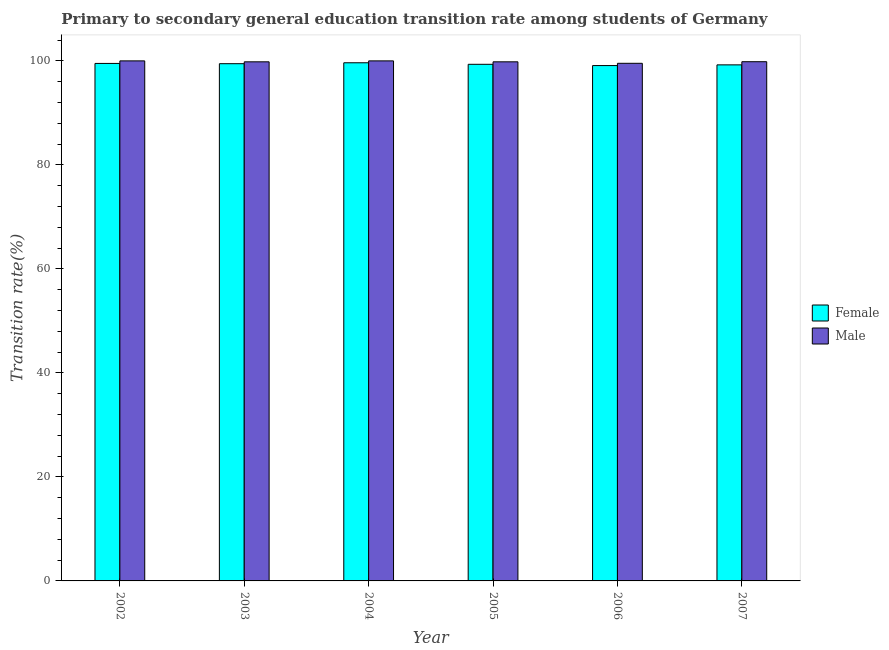How many groups of bars are there?
Make the answer very short. 6. Are the number of bars on each tick of the X-axis equal?
Your answer should be compact. Yes. What is the label of the 3rd group of bars from the left?
Ensure brevity in your answer.  2004. In how many cases, is the number of bars for a given year not equal to the number of legend labels?
Your answer should be very brief. 0. What is the transition rate among female students in 2007?
Your answer should be very brief. 99.23. Across all years, what is the maximum transition rate among male students?
Give a very brief answer. 100. Across all years, what is the minimum transition rate among female students?
Offer a terse response. 99.1. In which year was the transition rate among female students maximum?
Ensure brevity in your answer.  2004. In which year was the transition rate among female students minimum?
Keep it short and to the point. 2006. What is the total transition rate among female students in the graph?
Offer a very short reply. 596.28. What is the difference between the transition rate among female students in 2006 and that in 2007?
Keep it short and to the point. -0.13. What is the difference between the transition rate among male students in 2002 and the transition rate among female students in 2004?
Your answer should be very brief. 0. What is the average transition rate among male students per year?
Keep it short and to the point. 99.84. In the year 2003, what is the difference between the transition rate among female students and transition rate among male students?
Provide a succinct answer. 0. What is the ratio of the transition rate among female students in 2005 to that in 2006?
Provide a succinct answer. 1. Is the transition rate among female students in 2003 less than that in 2006?
Your answer should be very brief. No. What is the difference between the highest and the lowest transition rate among female students?
Provide a succinct answer. 0.54. In how many years, is the transition rate among female students greater than the average transition rate among female students taken over all years?
Provide a short and direct response. 3. Is the sum of the transition rate among female students in 2003 and 2007 greater than the maximum transition rate among male students across all years?
Provide a succinct answer. Yes. What does the 2nd bar from the left in 2004 represents?
Provide a succinct answer. Male. What does the 2nd bar from the right in 2006 represents?
Provide a short and direct response. Female. How many bars are there?
Ensure brevity in your answer.  12. How many years are there in the graph?
Keep it short and to the point. 6. Are the values on the major ticks of Y-axis written in scientific E-notation?
Your response must be concise. No. Does the graph contain any zero values?
Offer a very short reply. No. Does the graph contain grids?
Your response must be concise. No. Where does the legend appear in the graph?
Provide a succinct answer. Center right. What is the title of the graph?
Provide a short and direct response. Primary to secondary general education transition rate among students of Germany. Does "Formally registered" appear as one of the legend labels in the graph?
Your answer should be compact. No. What is the label or title of the Y-axis?
Offer a very short reply. Transition rate(%). What is the Transition rate(%) in Female in 2002?
Ensure brevity in your answer.  99.51. What is the Transition rate(%) in Female in 2003?
Offer a terse response. 99.46. What is the Transition rate(%) of Male in 2003?
Give a very brief answer. 99.82. What is the Transition rate(%) in Female in 2004?
Offer a very short reply. 99.64. What is the Transition rate(%) in Male in 2004?
Keep it short and to the point. 100. What is the Transition rate(%) in Female in 2005?
Give a very brief answer. 99.34. What is the Transition rate(%) in Male in 2005?
Offer a terse response. 99.82. What is the Transition rate(%) in Female in 2006?
Make the answer very short. 99.1. What is the Transition rate(%) in Male in 2006?
Offer a terse response. 99.53. What is the Transition rate(%) of Female in 2007?
Ensure brevity in your answer.  99.23. What is the Transition rate(%) in Male in 2007?
Offer a terse response. 99.84. Across all years, what is the maximum Transition rate(%) in Female?
Offer a terse response. 99.64. Across all years, what is the minimum Transition rate(%) of Female?
Offer a terse response. 99.1. Across all years, what is the minimum Transition rate(%) in Male?
Your response must be concise. 99.53. What is the total Transition rate(%) in Female in the graph?
Provide a succinct answer. 596.28. What is the total Transition rate(%) of Male in the graph?
Provide a succinct answer. 599.01. What is the difference between the Transition rate(%) in Female in 2002 and that in 2003?
Your answer should be very brief. 0.05. What is the difference between the Transition rate(%) in Male in 2002 and that in 2003?
Your answer should be compact. 0.18. What is the difference between the Transition rate(%) of Female in 2002 and that in 2004?
Make the answer very short. -0.13. What is the difference between the Transition rate(%) of Female in 2002 and that in 2005?
Your answer should be compact. 0.17. What is the difference between the Transition rate(%) of Male in 2002 and that in 2005?
Keep it short and to the point. 0.18. What is the difference between the Transition rate(%) of Female in 2002 and that in 2006?
Provide a succinct answer. 0.41. What is the difference between the Transition rate(%) of Male in 2002 and that in 2006?
Make the answer very short. 0.47. What is the difference between the Transition rate(%) of Female in 2002 and that in 2007?
Offer a very short reply. 0.28. What is the difference between the Transition rate(%) of Male in 2002 and that in 2007?
Give a very brief answer. 0.16. What is the difference between the Transition rate(%) of Female in 2003 and that in 2004?
Make the answer very short. -0.18. What is the difference between the Transition rate(%) in Male in 2003 and that in 2004?
Your response must be concise. -0.18. What is the difference between the Transition rate(%) of Female in 2003 and that in 2005?
Your answer should be very brief. 0.12. What is the difference between the Transition rate(%) in Male in 2003 and that in 2005?
Give a very brief answer. 0. What is the difference between the Transition rate(%) in Female in 2003 and that in 2006?
Provide a succinct answer. 0.36. What is the difference between the Transition rate(%) in Male in 2003 and that in 2006?
Ensure brevity in your answer.  0.28. What is the difference between the Transition rate(%) of Female in 2003 and that in 2007?
Offer a terse response. 0.23. What is the difference between the Transition rate(%) of Male in 2003 and that in 2007?
Offer a very short reply. -0.02. What is the difference between the Transition rate(%) of Female in 2004 and that in 2005?
Ensure brevity in your answer.  0.3. What is the difference between the Transition rate(%) of Male in 2004 and that in 2005?
Make the answer very short. 0.18. What is the difference between the Transition rate(%) of Female in 2004 and that in 2006?
Ensure brevity in your answer.  0.54. What is the difference between the Transition rate(%) in Male in 2004 and that in 2006?
Provide a succinct answer. 0.47. What is the difference between the Transition rate(%) of Female in 2004 and that in 2007?
Offer a very short reply. 0.41. What is the difference between the Transition rate(%) in Male in 2004 and that in 2007?
Your response must be concise. 0.16. What is the difference between the Transition rate(%) of Female in 2005 and that in 2006?
Your answer should be very brief. 0.24. What is the difference between the Transition rate(%) in Male in 2005 and that in 2006?
Your answer should be very brief. 0.28. What is the difference between the Transition rate(%) of Female in 2005 and that in 2007?
Provide a short and direct response. 0.11. What is the difference between the Transition rate(%) of Male in 2005 and that in 2007?
Ensure brevity in your answer.  -0.02. What is the difference between the Transition rate(%) in Female in 2006 and that in 2007?
Offer a very short reply. -0.13. What is the difference between the Transition rate(%) in Male in 2006 and that in 2007?
Ensure brevity in your answer.  -0.3. What is the difference between the Transition rate(%) of Female in 2002 and the Transition rate(%) of Male in 2003?
Your response must be concise. -0.31. What is the difference between the Transition rate(%) in Female in 2002 and the Transition rate(%) in Male in 2004?
Provide a short and direct response. -0.49. What is the difference between the Transition rate(%) in Female in 2002 and the Transition rate(%) in Male in 2005?
Your answer should be very brief. -0.31. What is the difference between the Transition rate(%) of Female in 2002 and the Transition rate(%) of Male in 2006?
Ensure brevity in your answer.  -0.02. What is the difference between the Transition rate(%) of Female in 2002 and the Transition rate(%) of Male in 2007?
Your response must be concise. -0.33. What is the difference between the Transition rate(%) in Female in 2003 and the Transition rate(%) in Male in 2004?
Offer a terse response. -0.54. What is the difference between the Transition rate(%) of Female in 2003 and the Transition rate(%) of Male in 2005?
Give a very brief answer. -0.36. What is the difference between the Transition rate(%) in Female in 2003 and the Transition rate(%) in Male in 2006?
Offer a very short reply. -0.08. What is the difference between the Transition rate(%) in Female in 2003 and the Transition rate(%) in Male in 2007?
Ensure brevity in your answer.  -0.38. What is the difference between the Transition rate(%) in Female in 2004 and the Transition rate(%) in Male in 2005?
Your answer should be compact. -0.18. What is the difference between the Transition rate(%) of Female in 2004 and the Transition rate(%) of Male in 2006?
Your answer should be compact. 0.1. What is the difference between the Transition rate(%) of Female in 2004 and the Transition rate(%) of Male in 2007?
Keep it short and to the point. -0.2. What is the difference between the Transition rate(%) in Female in 2005 and the Transition rate(%) in Male in 2006?
Provide a short and direct response. -0.19. What is the difference between the Transition rate(%) of Female in 2005 and the Transition rate(%) of Male in 2007?
Offer a very short reply. -0.5. What is the difference between the Transition rate(%) in Female in 2006 and the Transition rate(%) in Male in 2007?
Your answer should be compact. -0.74. What is the average Transition rate(%) in Female per year?
Offer a terse response. 99.38. What is the average Transition rate(%) in Male per year?
Ensure brevity in your answer.  99.84. In the year 2002, what is the difference between the Transition rate(%) in Female and Transition rate(%) in Male?
Your answer should be very brief. -0.49. In the year 2003, what is the difference between the Transition rate(%) of Female and Transition rate(%) of Male?
Provide a succinct answer. -0.36. In the year 2004, what is the difference between the Transition rate(%) of Female and Transition rate(%) of Male?
Offer a terse response. -0.36. In the year 2005, what is the difference between the Transition rate(%) in Female and Transition rate(%) in Male?
Provide a succinct answer. -0.48. In the year 2006, what is the difference between the Transition rate(%) of Female and Transition rate(%) of Male?
Ensure brevity in your answer.  -0.44. In the year 2007, what is the difference between the Transition rate(%) in Female and Transition rate(%) in Male?
Provide a short and direct response. -0.61. What is the ratio of the Transition rate(%) in Female in 2002 to that in 2004?
Provide a succinct answer. 1. What is the ratio of the Transition rate(%) in Male in 2002 to that in 2004?
Offer a terse response. 1. What is the ratio of the Transition rate(%) in Female in 2002 to that in 2005?
Provide a short and direct response. 1. What is the ratio of the Transition rate(%) of Male in 2002 to that in 2005?
Provide a succinct answer. 1. What is the ratio of the Transition rate(%) of Male in 2002 to that in 2006?
Keep it short and to the point. 1. What is the ratio of the Transition rate(%) in Male in 2003 to that in 2005?
Your answer should be compact. 1. What is the ratio of the Transition rate(%) of Female in 2003 to that in 2006?
Keep it short and to the point. 1. What is the ratio of the Transition rate(%) of Female in 2004 to that in 2005?
Provide a short and direct response. 1. What is the ratio of the Transition rate(%) in Female in 2004 to that in 2006?
Offer a very short reply. 1.01. What is the ratio of the Transition rate(%) in Female in 2004 to that in 2007?
Make the answer very short. 1. What is the ratio of the Transition rate(%) in Male in 2005 to that in 2006?
Make the answer very short. 1. What is the ratio of the Transition rate(%) in Male in 2006 to that in 2007?
Offer a very short reply. 1. What is the difference between the highest and the second highest Transition rate(%) of Female?
Give a very brief answer. 0.13. What is the difference between the highest and the second highest Transition rate(%) of Male?
Ensure brevity in your answer.  0. What is the difference between the highest and the lowest Transition rate(%) in Female?
Give a very brief answer. 0.54. What is the difference between the highest and the lowest Transition rate(%) of Male?
Ensure brevity in your answer.  0.47. 